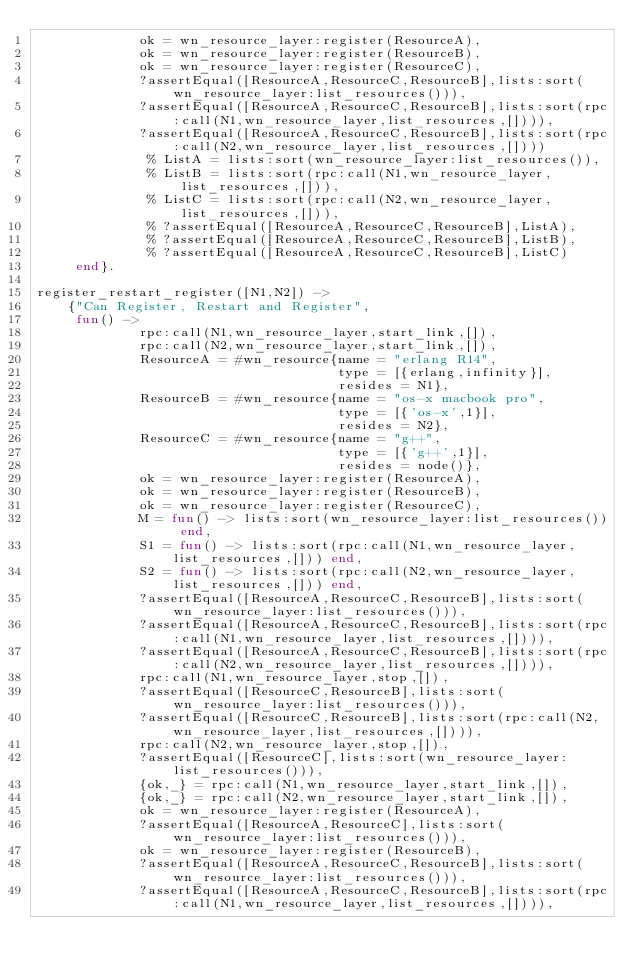<code> <loc_0><loc_0><loc_500><loc_500><_Erlang_>             ok = wn_resource_layer:register(ResourceA),
             ok = wn_resource_layer:register(ResourceB),
             ok = wn_resource_layer:register(ResourceC),
             ?assertEqual([ResourceA,ResourceC,ResourceB],lists:sort(wn_resource_layer:list_resources())),
             ?assertEqual([ResourceA,ResourceC,ResourceB],lists:sort(rpc:call(N1,wn_resource_layer,list_resources,[]))),
             ?assertEqual([ResourceA,ResourceC,ResourceB],lists:sort(rpc:call(N2,wn_resource_layer,list_resources,[])))
              % ListA = lists:sort(wn_resource_layer:list_resources()),
              % ListB = lists:sort(rpc:call(N1,wn_resource_layer,list_resources,[])),
              % ListC = lists:sort(rpc:call(N2,wn_resource_layer,list_resources,[])),
              % ?assertEqual([ResourceA,ResourceC,ResourceB],ListA),
              % ?assertEqual([ResourceA,ResourceC,ResourceB],ListB),
              % ?assertEqual([ResourceA,ResourceC,ResourceB],ListC)
     end}.

register_restart_register([N1,N2]) ->
    {"Can Register, Restart and Register",
     fun() ->
             rpc:call(N1,wn_resource_layer,start_link,[]),
             rpc:call(N2,wn_resource_layer,start_link,[]),
             ResourceA = #wn_resource{name = "erlang R14",
                                      type = [{erlang,infinity}],
                                      resides = N1},
             ResourceB = #wn_resource{name = "os-x macbook pro",
                                      type = [{'os-x',1}],
                                      resides = N2},
             ResourceC = #wn_resource{name = "g++",
                                      type = [{'g++',1}],
                                      resides = node()},
             ok = wn_resource_layer:register(ResourceA),
             ok = wn_resource_layer:register(ResourceB),
             ok = wn_resource_layer:register(ResourceC),
             M = fun() -> lists:sort(wn_resource_layer:list_resources()) end,
             S1 = fun() -> lists:sort(rpc:call(N1,wn_resource_layer,list_resources,[])) end,
             S2 = fun() -> lists:sort(rpc:call(N2,wn_resource_layer,list_resources,[])) end,
             ?assertEqual([ResourceA,ResourceC,ResourceB],lists:sort(wn_resource_layer:list_resources())),
             ?assertEqual([ResourceA,ResourceC,ResourceB],lists:sort(rpc:call(N1,wn_resource_layer,list_resources,[]))),
             ?assertEqual([ResourceA,ResourceC,ResourceB],lists:sort(rpc:call(N2,wn_resource_layer,list_resources,[]))),
             rpc:call(N1,wn_resource_layer,stop,[]),
             ?assertEqual([ResourceC,ResourceB],lists:sort(wn_resource_layer:list_resources())),
             ?assertEqual([ResourceC,ResourceB],lists:sort(rpc:call(N2,wn_resource_layer,list_resources,[]))),
             rpc:call(N2,wn_resource_layer,stop,[]),
             ?assertEqual([ResourceC],lists:sort(wn_resource_layer:list_resources())),
             {ok,_} = rpc:call(N1,wn_resource_layer,start_link,[]),
             {ok,_} = rpc:call(N2,wn_resource_layer,start_link,[]),
             ok = wn_resource_layer:register(ResourceA),
             ?assertEqual([ResourceA,ResourceC],lists:sort(wn_resource_layer:list_resources())),
             ok = wn_resource_layer:register(ResourceB),
             ?assertEqual([ResourceA,ResourceC,ResourceB],lists:sort(wn_resource_layer:list_resources())),
             ?assertEqual([ResourceA,ResourceC,ResourceB],lists:sort(rpc:call(N1,wn_resource_layer,list_resources,[]))),</code> 